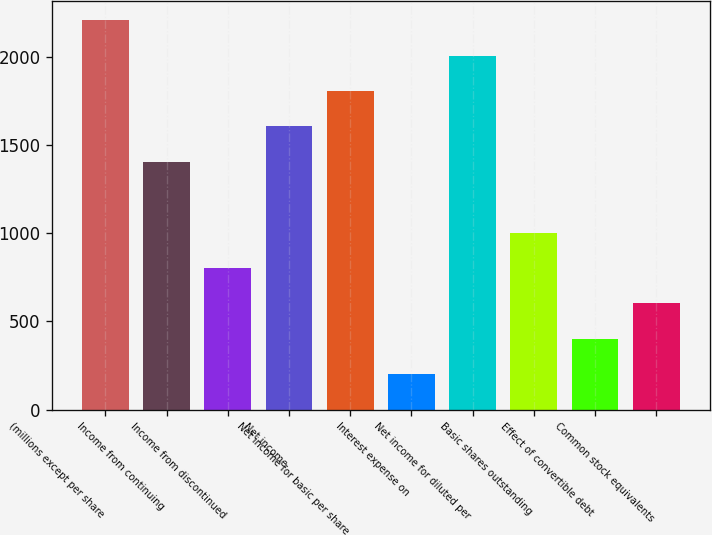Convert chart. <chart><loc_0><loc_0><loc_500><loc_500><bar_chart><fcel>(millions except per share<fcel>Income from continuing<fcel>Income from discontinued<fcel>Net income<fcel>Net income for basic per share<fcel>Interest expense on<fcel>Net income for diluted per<fcel>Basic shares outstanding<fcel>Effect of convertible debt<fcel>Common stock equivalents<nl><fcel>2207.61<fcel>1405.08<fcel>803.18<fcel>1605.71<fcel>1806.35<fcel>201.28<fcel>2006.98<fcel>1003.81<fcel>401.91<fcel>602.55<nl></chart> 